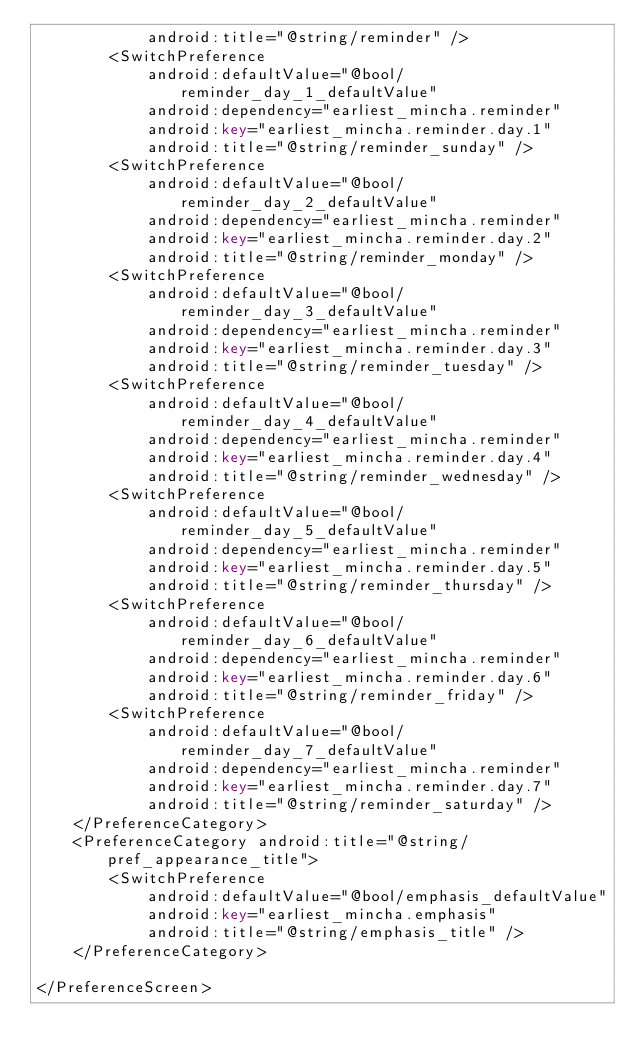Convert code to text. <code><loc_0><loc_0><loc_500><loc_500><_XML_>            android:title="@string/reminder" />
        <SwitchPreference
            android:defaultValue="@bool/reminder_day_1_defaultValue"
            android:dependency="earliest_mincha.reminder"
            android:key="earliest_mincha.reminder.day.1"
            android:title="@string/reminder_sunday" />
        <SwitchPreference
            android:defaultValue="@bool/reminder_day_2_defaultValue"
            android:dependency="earliest_mincha.reminder"
            android:key="earliest_mincha.reminder.day.2"
            android:title="@string/reminder_monday" />
        <SwitchPreference
            android:defaultValue="@bool/reminder_day_3_defaultValue"
            android:dependency="earliest_mincha.reminder"
            android:key="earliest_mincha.reminder.day.3"
            android:title="@string/reminder_tuesday" />
        <SwitchPreference
            android:defaultValue="@bool/reminder_day_4_defaultValue"
            android:dependency="earliest_mincha.reminder"
            android:key="earliest_mincha.reminder.day.4"
            android:title="@string/reminder_wednesday" />
        <SwitchPreference
            android:defaultValue="@bool/reminder_day_5_defaultValue"
            android:dependency="earliest_mincha.reminder"
            android:key="earliest_mincha.reminder.day.5"
            android:title="@string/reminder_thursday" />
        <SwitchPreference
            android:defaultValue="@bool/reminder_day_6_defaultValue"
            android:dependency="earliest_mincha.reminder"
            android:key="earliest_mincha.reminder.day.6"
            android:title="@string/reminder_friday" />
        <SwitchPreference
            android:defaultValue="@bool/reminder_day_7_defaultValue"
            android:dependency="earliest_mincha.reminder"
            android:key="earliest_mincha.reminder.day.7"
            android:title="@string/reminder_saturday" />
    </PreferenceCategory>
    <PreferenceCategory android:title="@string/pref_appearance_title">
        <SwitchPreference
            android:defaultValue="@bool/emphasis_defaultValue"
            android:key="earliest_mincha.emphasis"
            android:title="@string/emphasis_title" />
    </PreferenceCategory>

</PreferenceScreen></code> 